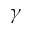<formula> <loc_0><loc_0><loc_500><loc_500>\gamma</formula> 